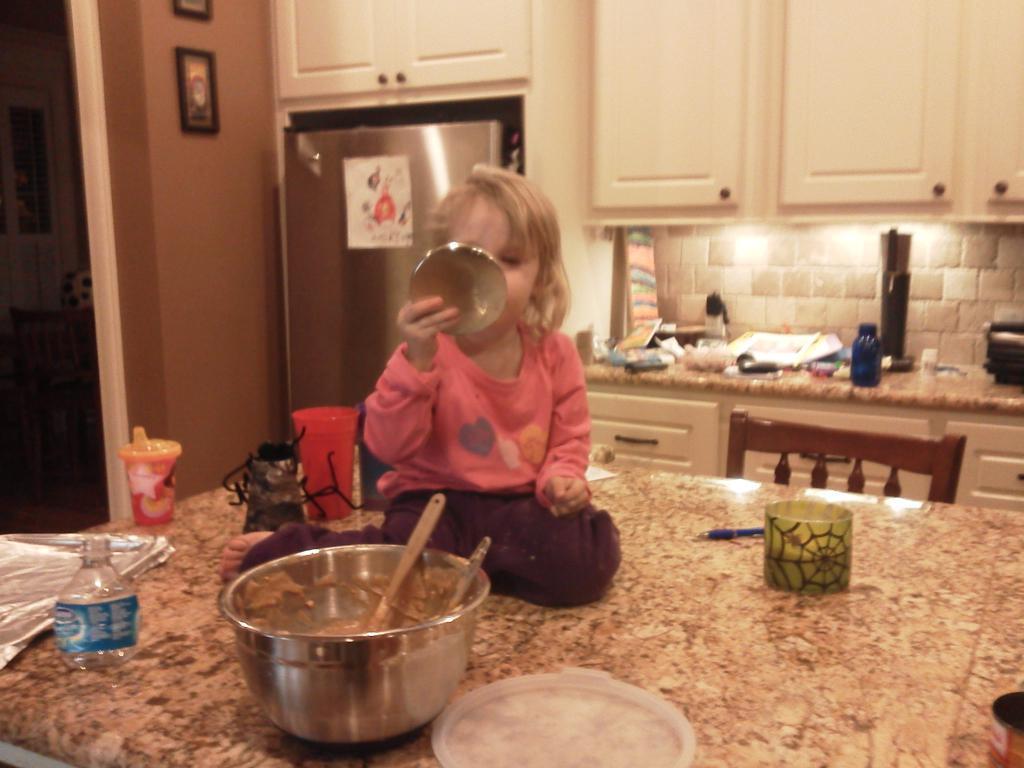Describe this image in one or two sentences. This picture shows a girl seated on the table and we see few cups and a bowl with couple of spoons in it and we see a bottle on the table and we see a refrigerator and a cupboard and couple photo frames on the wall and we see few bottles on the countertop and we see a chair. 